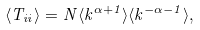<formula> <loc_0><loc_0><loc_500><loc_500>\langle T _ { i i } \rangle = N \langle k ^ { \alpha + 1 } \rangle \langle k ^ { - \alpha - 1 } \rangle ,</formula> 